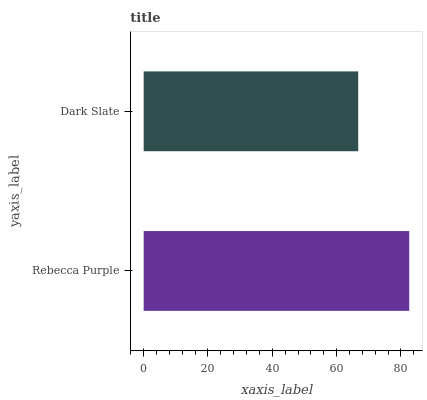Is Dark Slate the minimum?
Answer yes or no. Yes. Is Rebecca Purple the maximum?
Answer yes or no. Yes. Is Dark Slate the maximum?
Answer yes or no. No. Is Rebecca Purple greater than Dark Slate?
Answer yes or no. Yes. Is Dark Slate less than Rebecca Purple?
Answer yes or no. Yes. Is Dark Slate greater than Rebecca Purple?
Answer yes or no. No. Is Rebecca Purple less than Dark Slate?
Answer yes or no. No. Is Rebecca Purple the high median?
Answer yes or no. Yes. Is Dark Slate the low median?
Answer yes or no. Yes. Is Dark Slate the high median?
Answer yes or no. No. Is Rebecca Purple the low median?
Answer yes or no. No. 